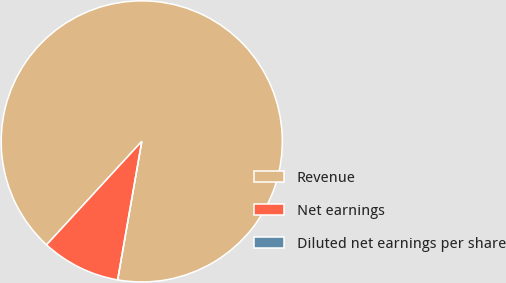Convert chart. <chart><loc_0><loc_0><loc_500><loc_500><pie_chart><fcel>Revenue<fcel>Net earnings<fcel>Diluted net earnings per share<nl><fcel>90.91%<fcel>9.09%<fcel>0.0%<nl></chart> 